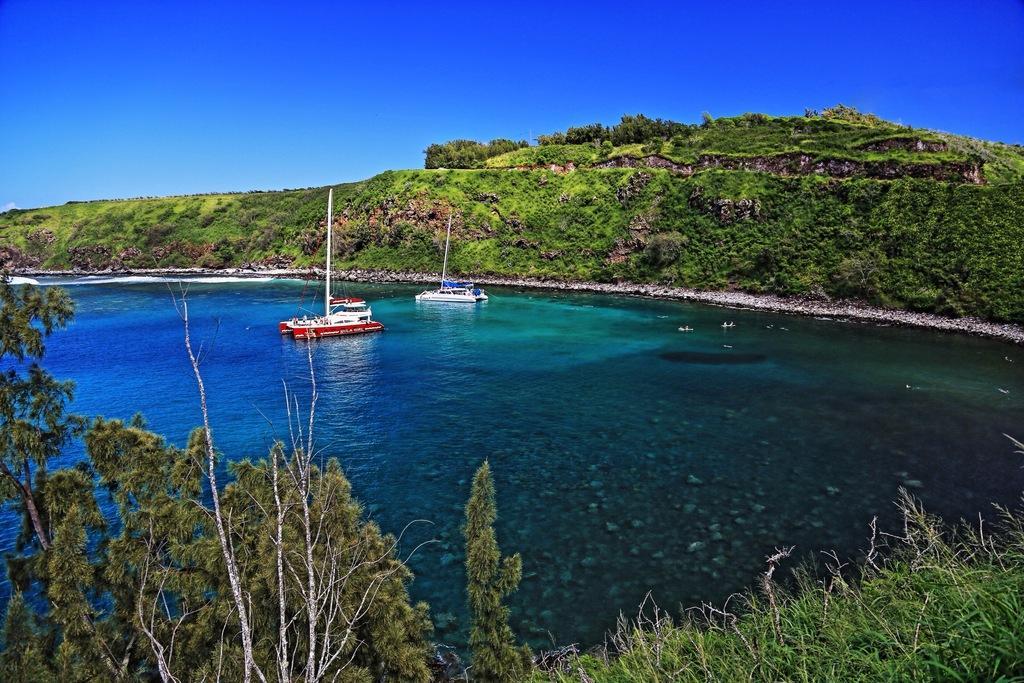Please provide a concise description of this image. In this picture we can see couple of boats in the water, in the background we can find few trees. 